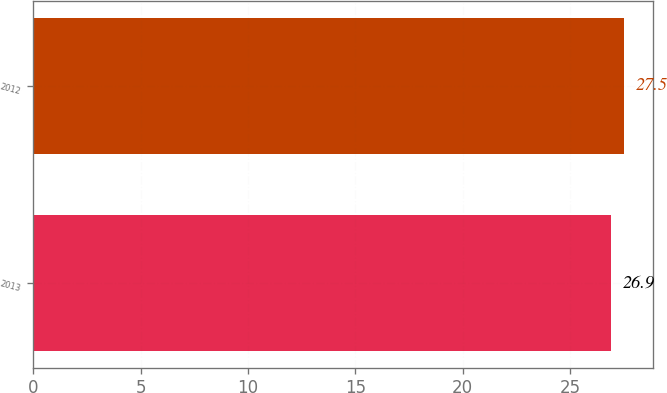<chart> <loc_0><loc_0><loc_500><loc_500><bar_chart><fcel>2013<fcel>2012<nl><fcel>26.9<fcel>27.5<nl></chart> 